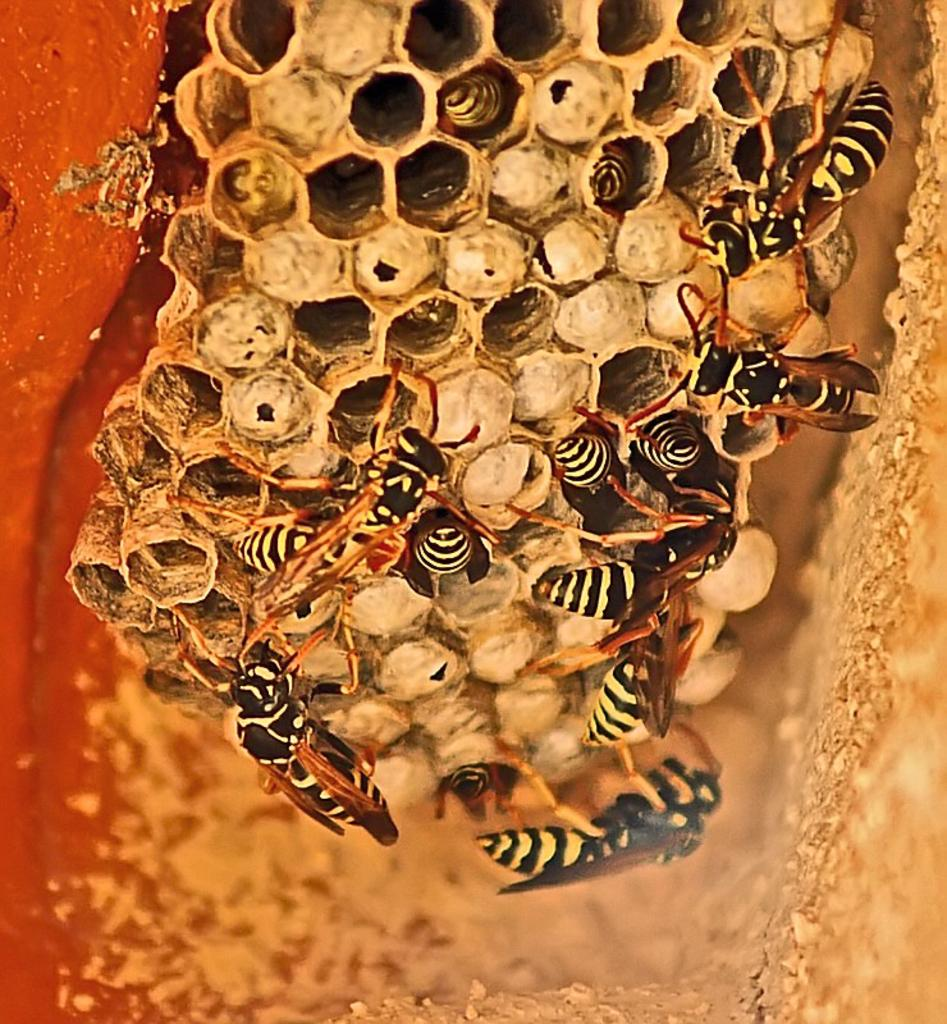What insects can be seen in the image? There are bees in the image. Where are the bees located? The bees are on a honeycomb. How many books can be seen in the image? There are no books present in the image. The image features bees on a honeycomb. 